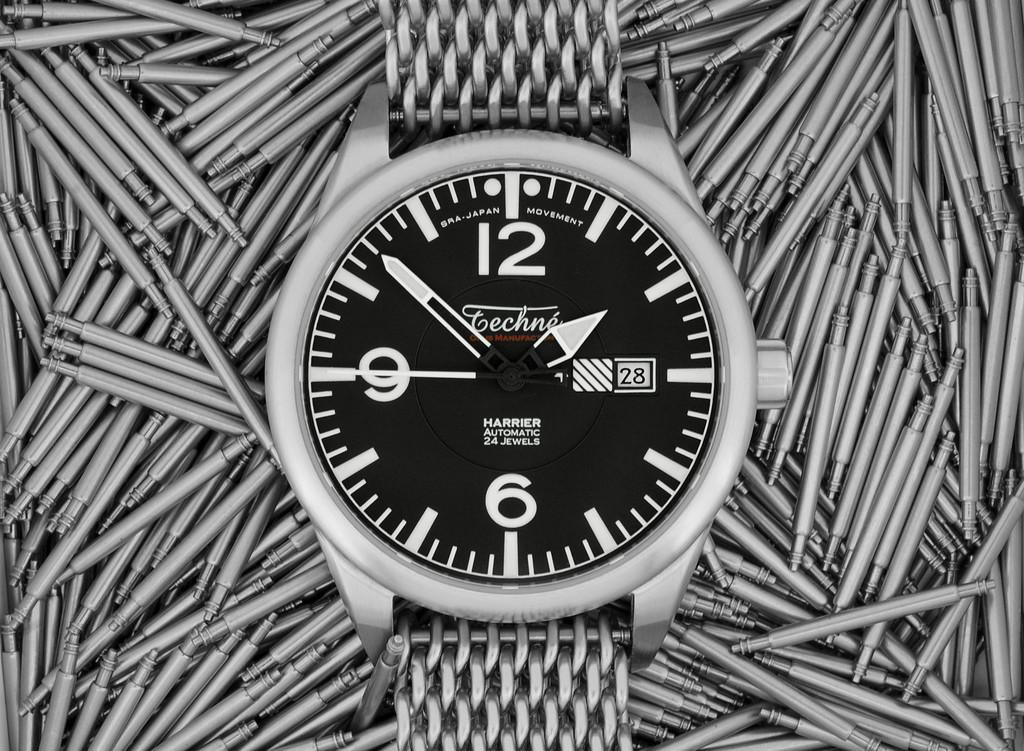<image>
Write a terse but informative summary of the picture. A Harrier black and silver watch displays the time of 1:52. 